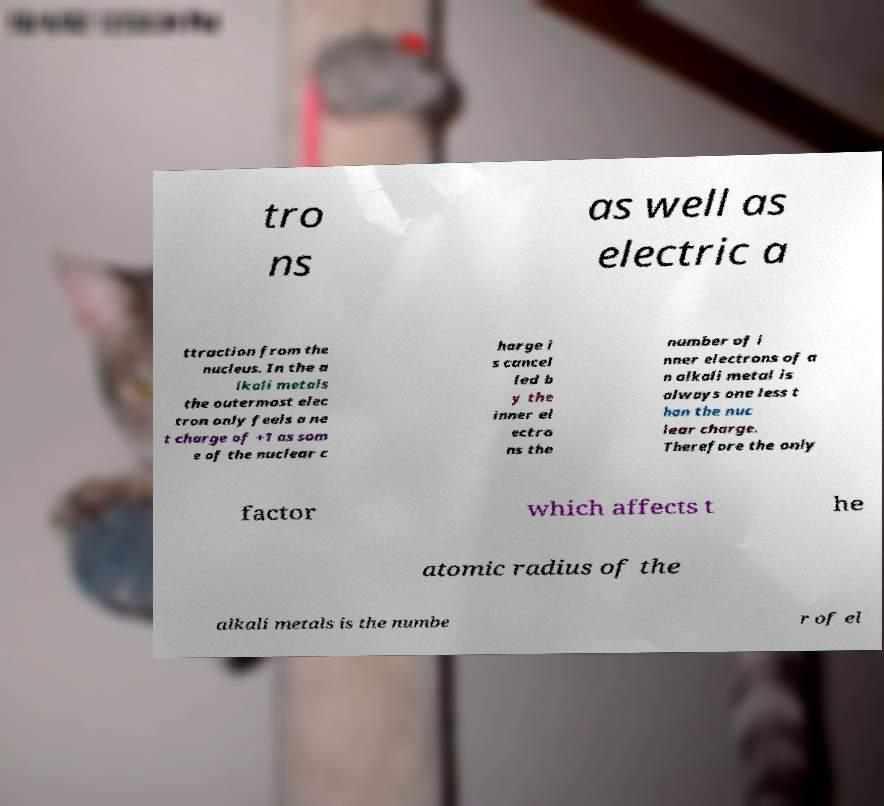What messages or text are displayed in this image? I need them in a readable, typed format. tro ns as well as electric a ttraction from the nucleus. In the a lkali metals the outermost elec tron only feels a ne t charge of +1 as som e of the nuclear c harge i s cancel led b y the inner el ectro ns the number of i nner electrons of a n alkali metal is always one less t han the nuc lear charge. Therefore the only factor which affects t he atomic radius of the alkali metals is the numbe r of el 